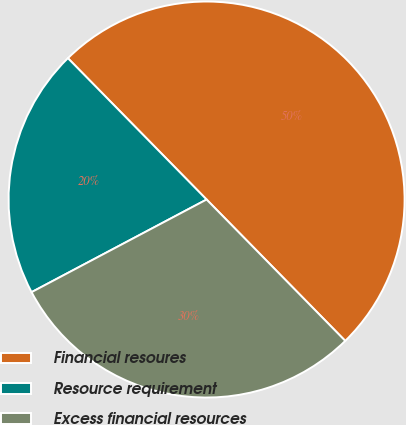Convert chart to OTSL. <chart><loc_0><loc_0><loc_500><loc_500><pie_chart><fcel>Financial resoures<fcel>Resource requirement<fcel>Excess financial resources<nl><fcel>50.0%<fcel>20.4%<fcel>29.6%<nl></chart> 